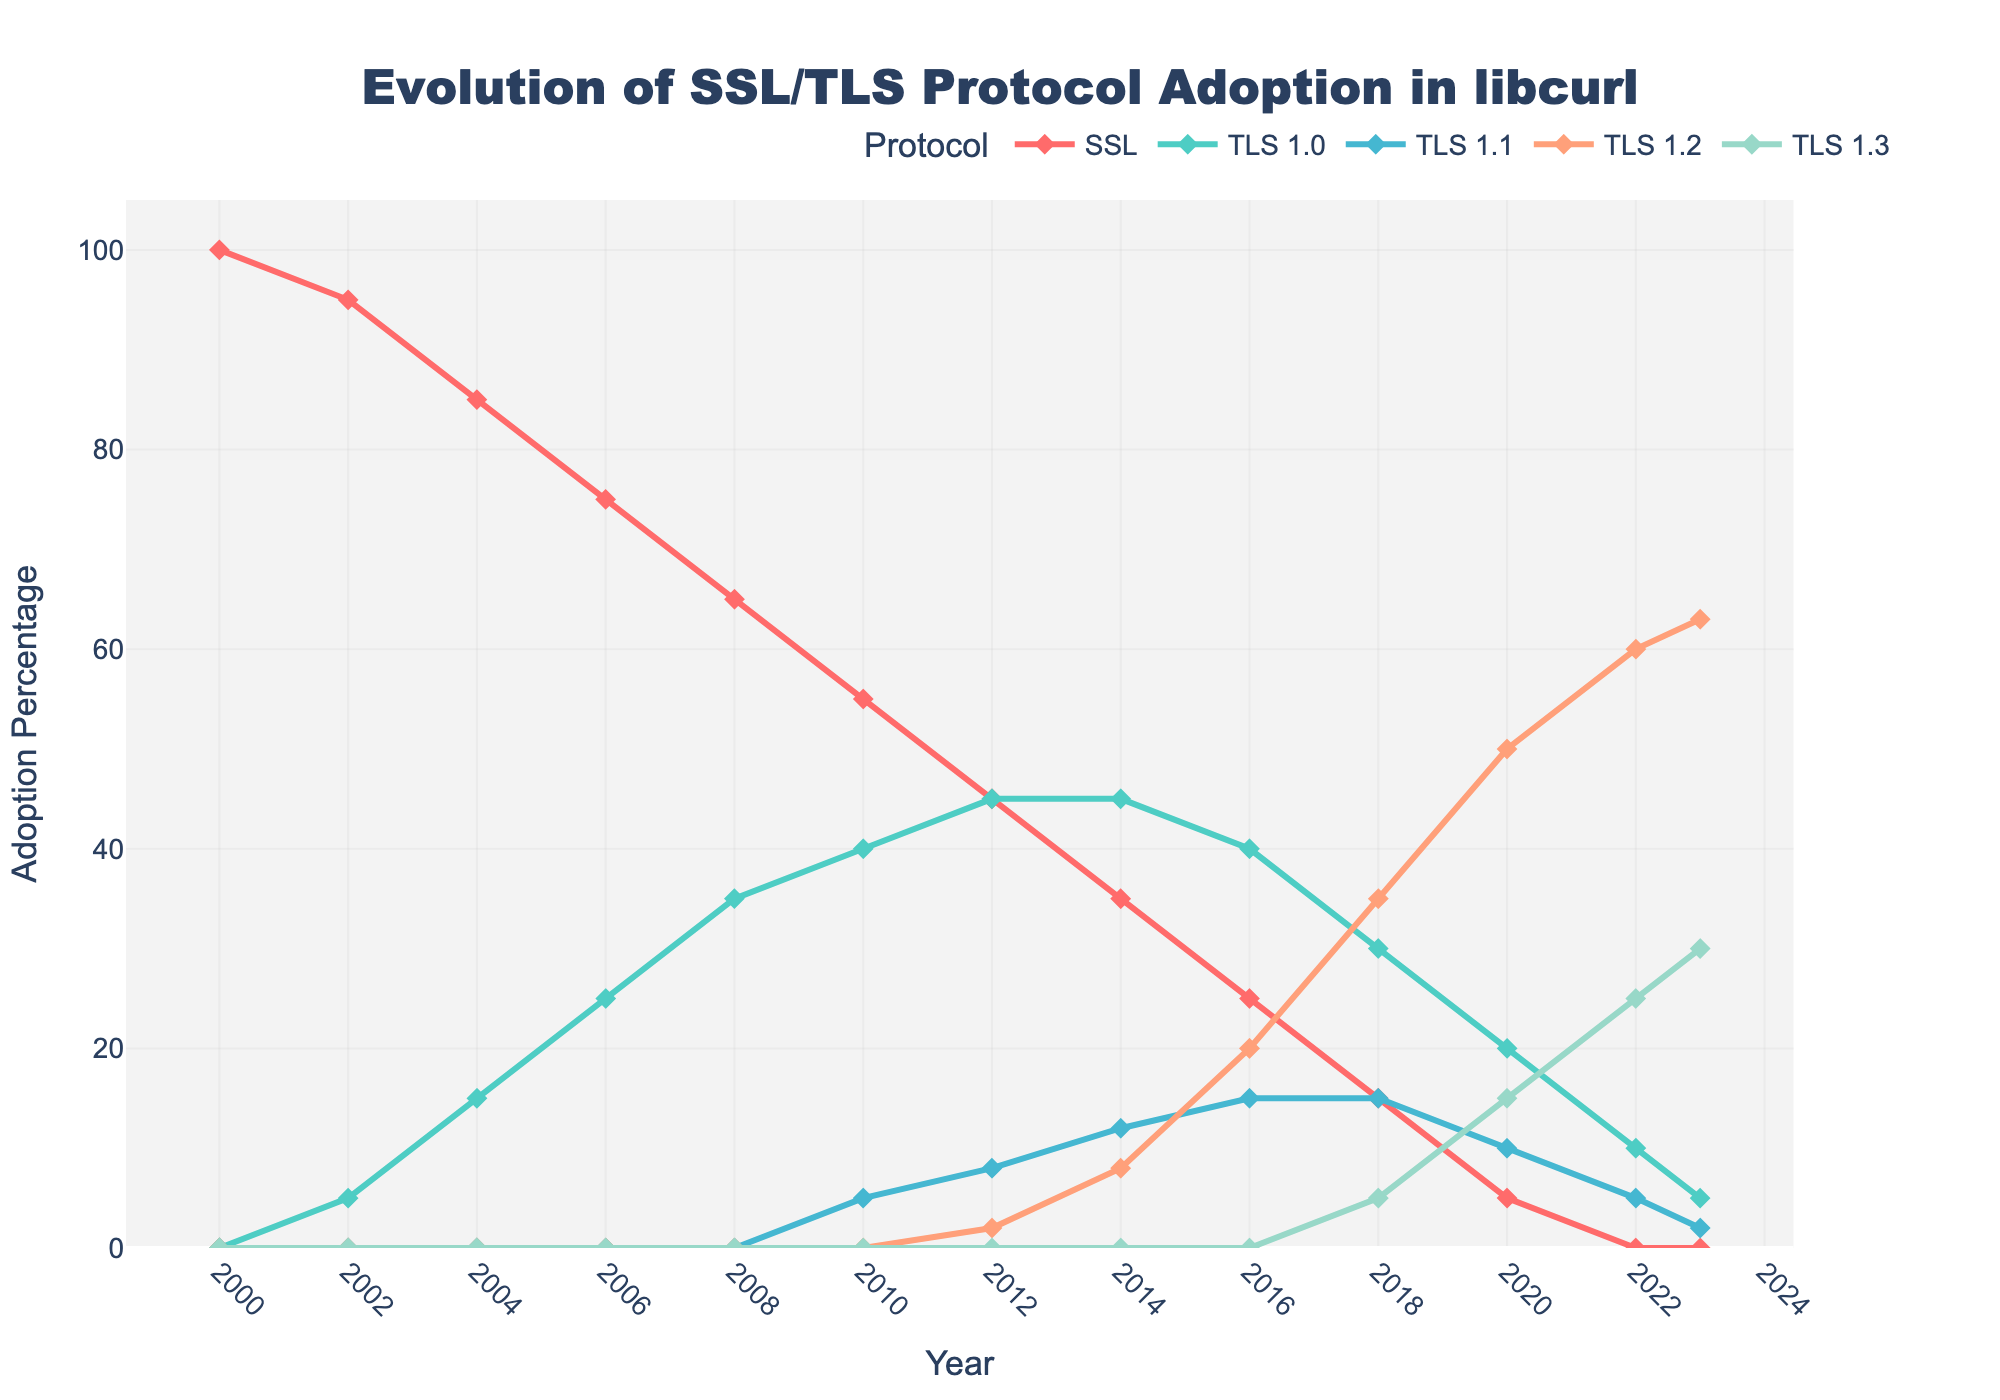How did the adoption of SSL change between 2000 and 2023? To determine the change in SSL adoption, we look at the data points for SSL in 2000 and 2023. In 2000, the adoption was 100%, and it reduced to 0% in 2023. The adoption decreased by 100%.
Answer: The adoption decreased by 100% Which protocol saw the most significant increase in adoption from 2010 to 2023? To find the protocol with the most significant increase, we compare the adoption percentages of all protocols between 2010 and 2023. SSL decreased from 55% to 0%, TLS 1.0 decreased from 40% to 5%, TLS 1.1 decreased from 5% to 2%, TLS 1.2 increased from 0% to 63%, and TLS 1.3 increased from 0% to 30%. TLS 1.2 saw the most significant increase.
Answer: TLS 1.2 In what year did the adoption of TLS 1.2 exceed that of SSL for the first time? To determine the first year TLS 1.2 adoption was higher than SSL, compare their values year by year. From 2016 onwards, TLS 1.2 adoption (20%) exceeds SSL adoption (25%).
Answer: 2016 What is the total adoption percentage of all protocols in 2016? To find the total adoption percentage in 2016, sum the percentages for SSL, TLS 1.0, TLS 1.1, TLS 1.2, and TLS 1.3. The values are 25%, 40%, 15%, 20%, and 0%, respectively. Summing them gives 25% + 40% + 15% + 20% + 0% = 100%.
Answer: 100% Between which years did TLS 1.2 see the fastest growth? To determine the period of fastest growth, look at the year-over-year changes. From 2014 to 2016, TLS 1.2 increased from 8% to 20% (a 12% increase), and from 2016 to 2018, it increased from 20% to 35% (a 15% increase). The fastest growth happened from 2016 to 2018.
Answer: 2016-2018 Which protocol had the highest adoption in 2023? To find the protocol with the highest adoption in 2023, compare the adoption percentages: SSL (0%), TLS 1.0 (5%), TLS 1.1 (2%), TLS 1.2 (63%), and TLS 1.3 (30%). TLS 1.2 has the highest adoption at 63%.
Answer: TLS 1.2 Compare the adoption rates of TLS 1.0 and TLS 1.2 in the year 2012. In 2012, TLS 1.0 had an adoption rate of 45%, and TLS 1.2 had 2%. Comparing these, TLS 1.0 had a higher adoption rate than TLS 1.2.
Answer: TLS 1.0 had a higher adoption rate What was the decrease in SSL adoption from 2008 to 2012? To find the decrease in SSL adoption, subtract the 2012 value (45%) from the 2008 value (65%), resulting in a 65% - 45% = 20% decrease.
Answer: 20% Which protocol had no adoption in 2020 and saw its first adoption in 2022? To determine which protocol first saw adoption in 2022, look for columns with 0% in 2020 and non-zero in 2022. TLS 1.3 met this criteria, increasing from 0% in 2020 to 25% in 2022.
Answer: TLS 1.3 